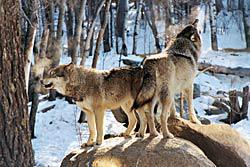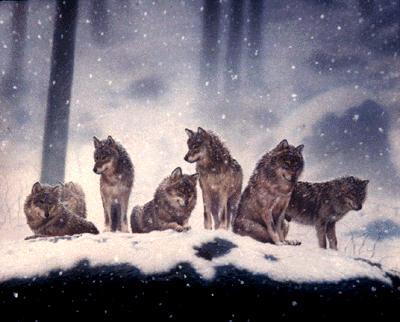The first image is the image on the left, the second image is the image on the right. Given the left and right images, does the statement "There is no more than two wolves in the left image." hold true? Answer yes or no. Yes. The first image is the image on the left, the second image is the image on the right. Analyze the images presented: Is the assertion "One image shows a wolf standing on snow in front of trees with its body turned rightward and its head facing the camera." valid? Answer yes or no. No. 